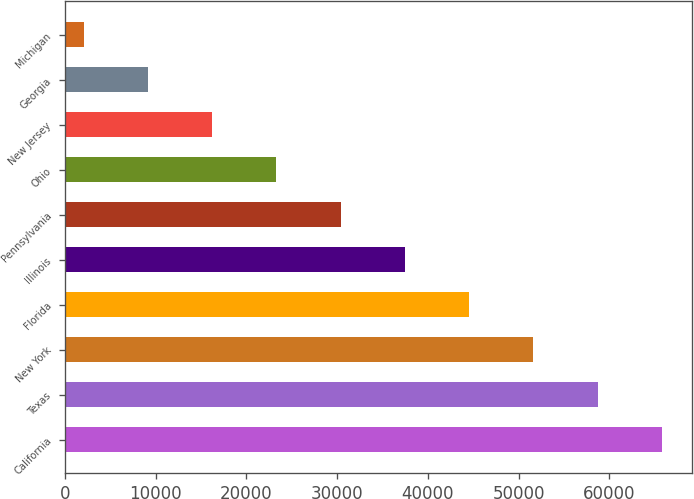<chart> <loc_0><loc_0><loc_500><loc_500><bar_chart><fcel>California<fcel>Texas<fcel>New York<fcel>Florida<fcel>Illinois<fcel>Pennsylvania<fcel>Ohio<fcel>New Jersey<fcel>Georgia<fcel>Michigan<nl><fcel>65792.6<fcel>58709.2<fcel>51625.8<fcel>44542.4<fcel>37459<fcel>30375.6<fcel>23292.2<fcel>16208.8<fcel>9125.4<fcel>2042<nl></chart> 